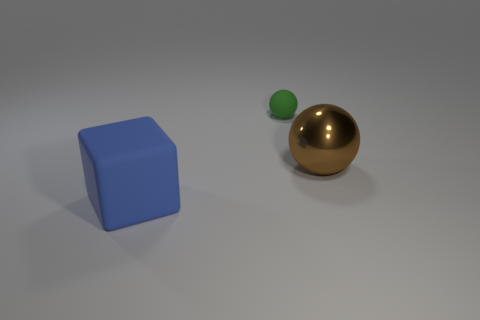There is another object that is the same shape as the small green matte thing; what is it made of?
Offer a very short reply. Metal. There is a object to the right of the rubber thing behind the rubber thing that is in front of the small green thing; what is its color?
Your answer should be very brief. Brown. What number of objects are either brown shiny things or rubber things?
Your response must be concise. 3. What number of blue rubber things are the same shape as the big brown metallic object?
Give a very brief answer. 0. Does the green sphere have the same material as the large object that is in front of the brown metal object?
Keep it short and to the point. Yes. What is the size of the blue block that is the same material as the small sphere?
Provide a succinct answer. Large. How big is the thing behind the metallic thing?
Your response must be concise. Small. How many matte cubes have the same size as the blue matte object?
Keep it short and to the point. 0. There is another thing that is the same size as the blue object; what is its color?
Make the answer very short. Brown. What color is the large matte cube?
Make the answer very short. Blue. 